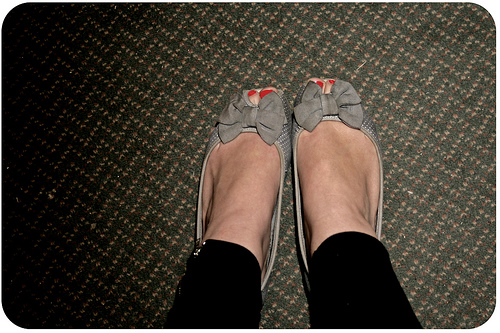<image>
Can you confirm if the bow is on the pants? No. The bow is not positioned on the pants. They may be near each other, but the bow is not supported by or resting on top of the pants. 